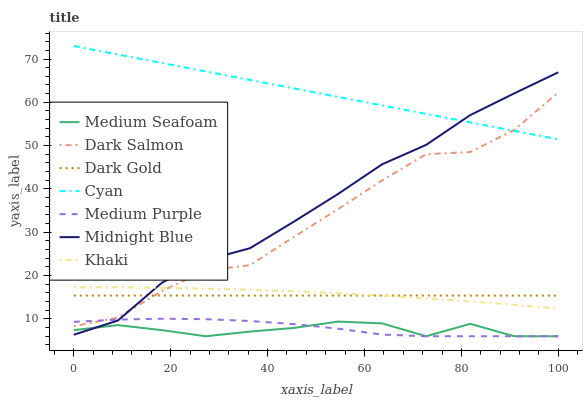Does Medium Seafoam have the minimum area under the curve?
Answer yes or no. Yes. Does Cyan have the maximum area under the curve?
Answer yes or no. Yes. Does Midnight Blue have the minimum area under the curve?
Answer yes or no. No. Does Midnight Blue have the maximum area under the curve?
Answer yes or no. No. Is Cyan the smoothest?
Answer yes or no. Yes. Is Dark Salmon the roughest?
Answer yes or no. Yes. Is Midnight Blue the smoothest?
Answer yes or no. No. Is Midnight Blue the roughest?
Answer yes or no. No. Does Medium Purple have the lowest value?
Answer yes or no. Yes. Does Midnight Blue have the lowest value?
Answer yes or no. No. Does Cyan have the highest value?
Answer yes or no. Yes. Does Midnight Blue have the highest value?
Answer yes or no. No. Is Medium Purple less than Dark Gold?
Answer yes or no. Yes. Is Cyan greater than Medium Purple?
Answer yes or no. Yes. Does Dark Salmon intersect Dark Gold?
Answer yes or no. Yes. Is Dark Salmon less than Dark Gold?
Answer yes or no. No. Is Dark Salmon greater than Dark Gold?
Answer yes or no. No. Does Medium Purple intersect Dark Gold?
Answer yes or no. No. 